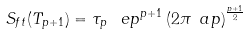<formula> <loc_0><loc_0><loc_500><loc_500>S _ { f t } ( T _ { p + 1 } ) = \tau _ { p } \, \ e p ^ { p + 1 } \left ( 2 \pi \ a p \right ) ^ { \frac { p + 1 } { 2 } }</formula> 